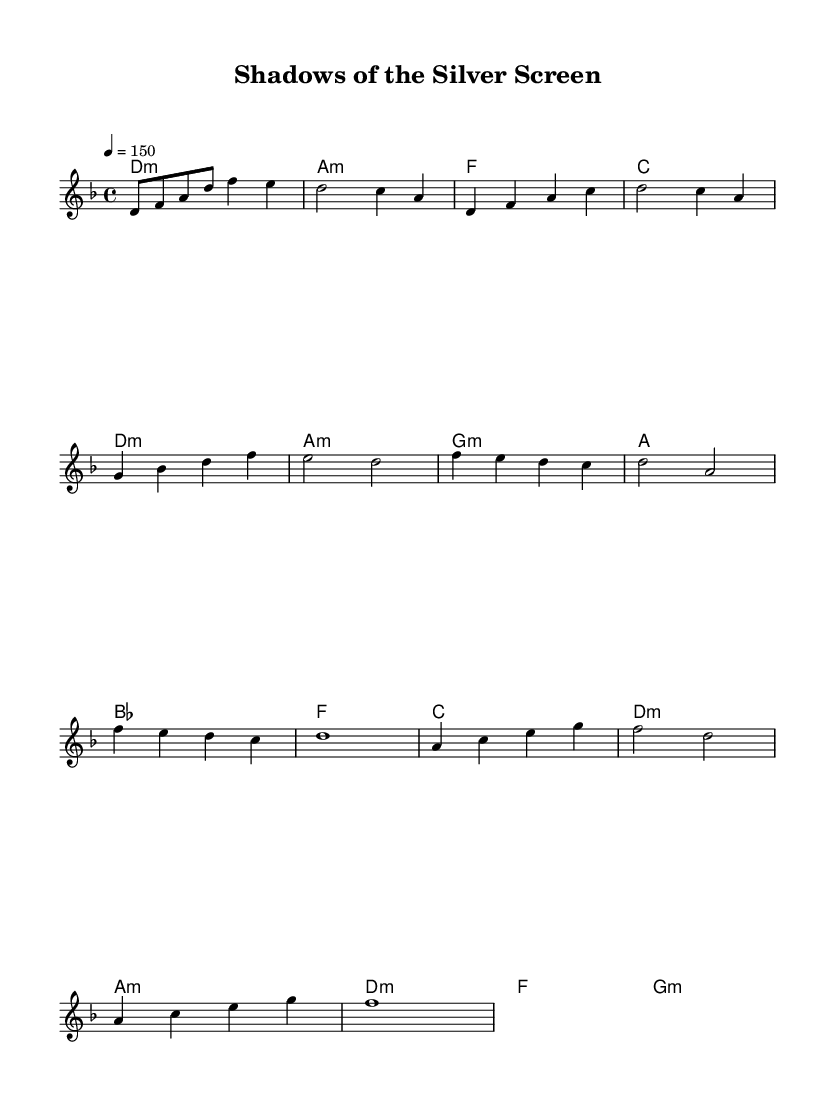What is the key signature of this music? The key signature shows one flat, indicating that the music is in the key of D minor. This is a common minor key often associated with more somber or dramatic themes.
Answer: D minor What is the time signature of this piece? The time signature is indicated as 4 over 4 at the beginning of the score. This denotes a common time signature, where there are four beats in each measure and the quarter note receives one beat.
Answer: 4/4 What is the tempo marking for this music? The tempo marking indicated is quarter note equals 150. This means that there are 150 quarter note beats per minute, suggesting a brisk pace typical in metal music.
Answer: 150 Which section features the bridge? The bridge in this score is identified between the chorus and the ending, as indicated by the chord changes and distinct melodic phrases present. The music shifts in texture and emotion during this section, reinforcing its role in transitioning themes.
Answer: Bridge What is the primary chord progression in the verse? The verse uses the chord progression of D minor, A minor, G minor, and A major. These chords create a moody atmosphere typical in theatrical power metal while reflecting emotional depth in the lyrics.
Answer: D minor, A minor, G minor, A major How many measures are in the chorus? The chorus consists of four measures, characterized by repeated phrases and a powerful vocal melody that emphasizes the theme, making it lyrically and musically prominent. This repetition is a common technique in metal to reinforce the main ideas.
Answer: 4 